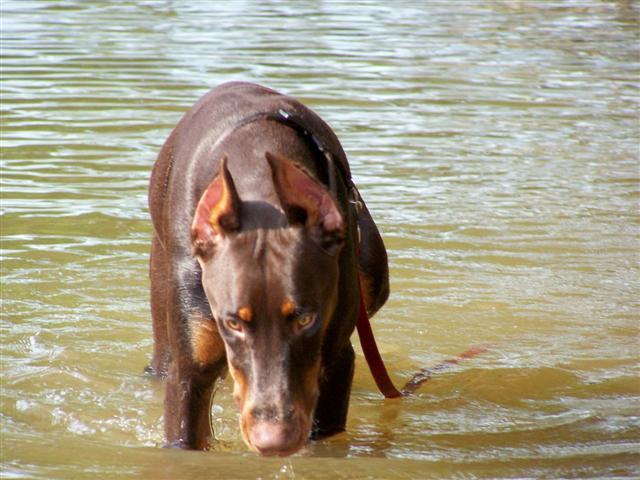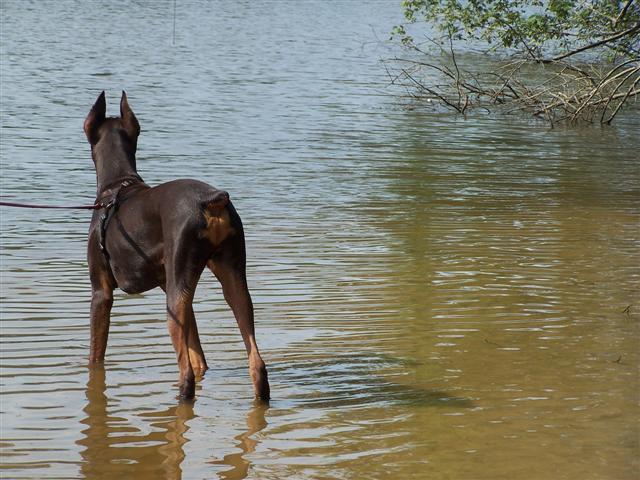The first image is the image on the left, the second image is the image on the right. Evaluate the accuracy of this statement regarding the images: "Three or more mammals are visible.". Is it true? Answer yes or no. No. The first image is the image on the left, the second image is the image on the right. For the images displayed, is the sentence "The right image shows a left-facing doberman creating a splash, with its front paws off the ground." factually correct? Answer yes or no. No. 